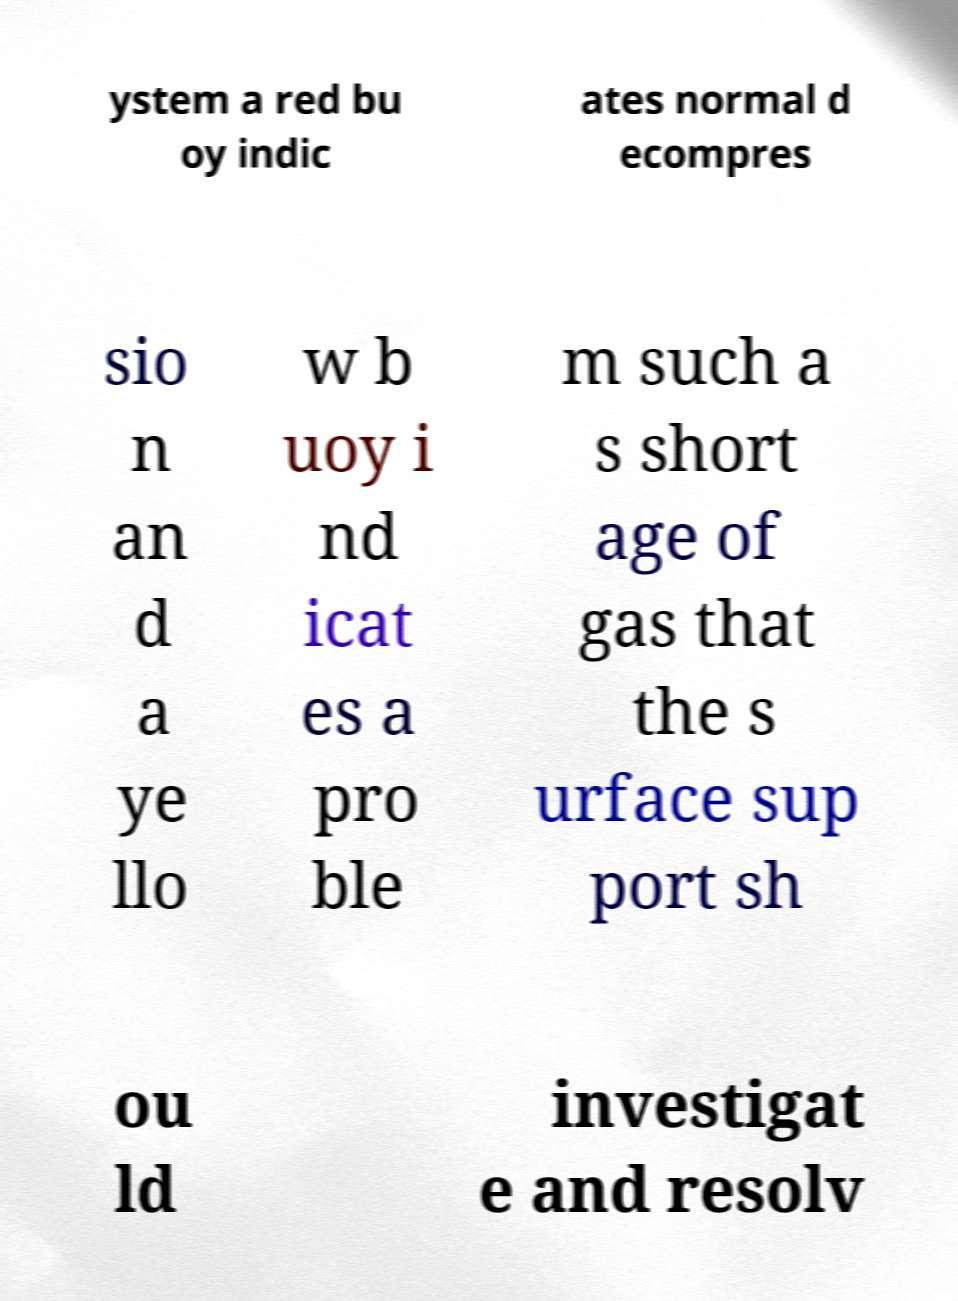Please read and relay the text visible in this image. What does it say? ystem a red bu oy indic ates normal d ecompres sio n an d a ye llo w b uoy i nd icat es a pro ble m such a s short age of gas that the s urface sup port sh ou ld investigat e and resolv 